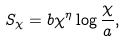Convert formula to latex. <formula><loc_0><loc_0><loc_500><loc_500>S _ { \chi } = b \chi ^ { \eta } \log \frac { \chi } { a } ,</formula> 